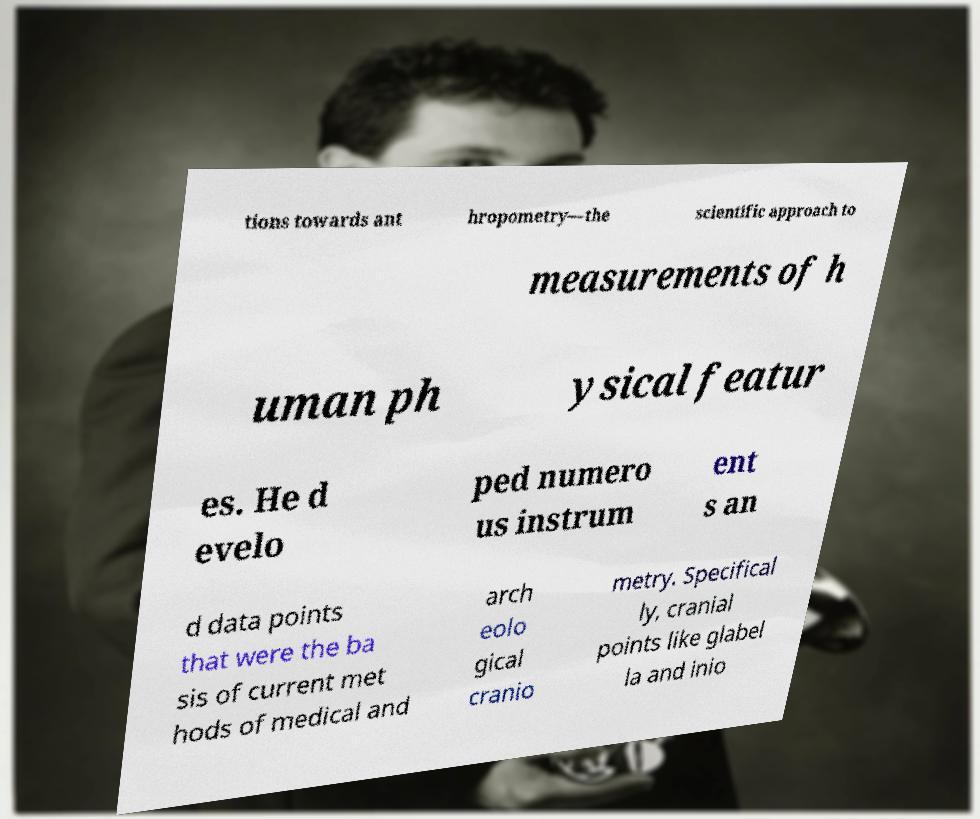Can you accurately transcribe the text from the provided image for me? tions towards ant hropometry—the scientific approach to measurements of h uman ph ysical featur es. He d evelo ped numero us instrum ent s an d data points that were the ba sis of current met hods of medical and arch eolo gical cranio metry. Specifical ly, cranial points like glabel la and inio 